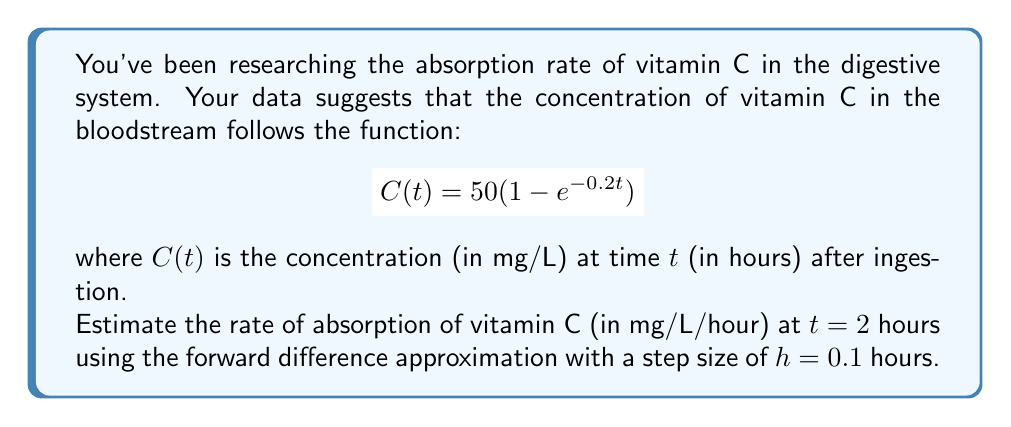Solve this math problem. To estimate the rate of absorption, we need to calculate the derivative of $C(t)$ at $t = 2$ using the forward difference approximation.

The forward difference formula is:

$$C'(t) \approx \frac{C(t + h) - C(t)}{h}$$

Step 1: Calculate $C(2)$
$$C(2) = 50(1 - e^{-0.2(2)}) = 50(1 - e^{-0.4}) \approx 32.97 \text{ mg/L}$$

Step 2: Calculate $C(2 + h) = C(2.1)$
$$C(2.1) = 50(1 - e^{-0.2(2.1)}) = 50(1 - e^{-0.42}) \approx 33.85 \text{ mg/L}$$

Step 3: Apply the forward difference formula
$$C'(2) \approx \frac{C(2.1) - C(2)}{0.1} = \frac{33.85 - 32.97}{0.1} \approx 8.80 \text{ mg/L/hour}$$

This approximation estimates the rate of absorption of vitamin C at 2 hours after ingestion.
Answer: 8.80 mg/L/hour 